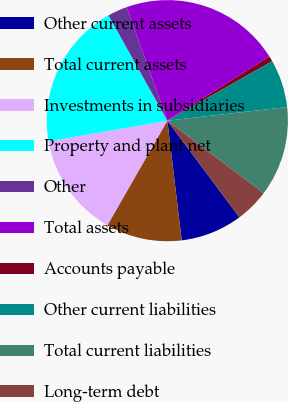Convert chart to OTSL. <chart><loc_0><loc_0><loc_500><loc_500><pie_chart><fcel>Other current assets<fcel>Total current assets<fcel>Investments in subsidiaries<fcel>Property and plant net<fcel>Other<fcel>Total assets<fcel>Accounts payable<fcel>Other current liabilities<fcel>Total current liabilities<fcel>Long-term debt<nl><fcel>8.3%<fcel>10.19%<fcel>13.97%<fcel>19.64%<fcel>2.63%<fcel>21.53%<fcel>0.74%<fcel>6.41%<fcel>12.08%<fcel>4.52%<nl></chart> 